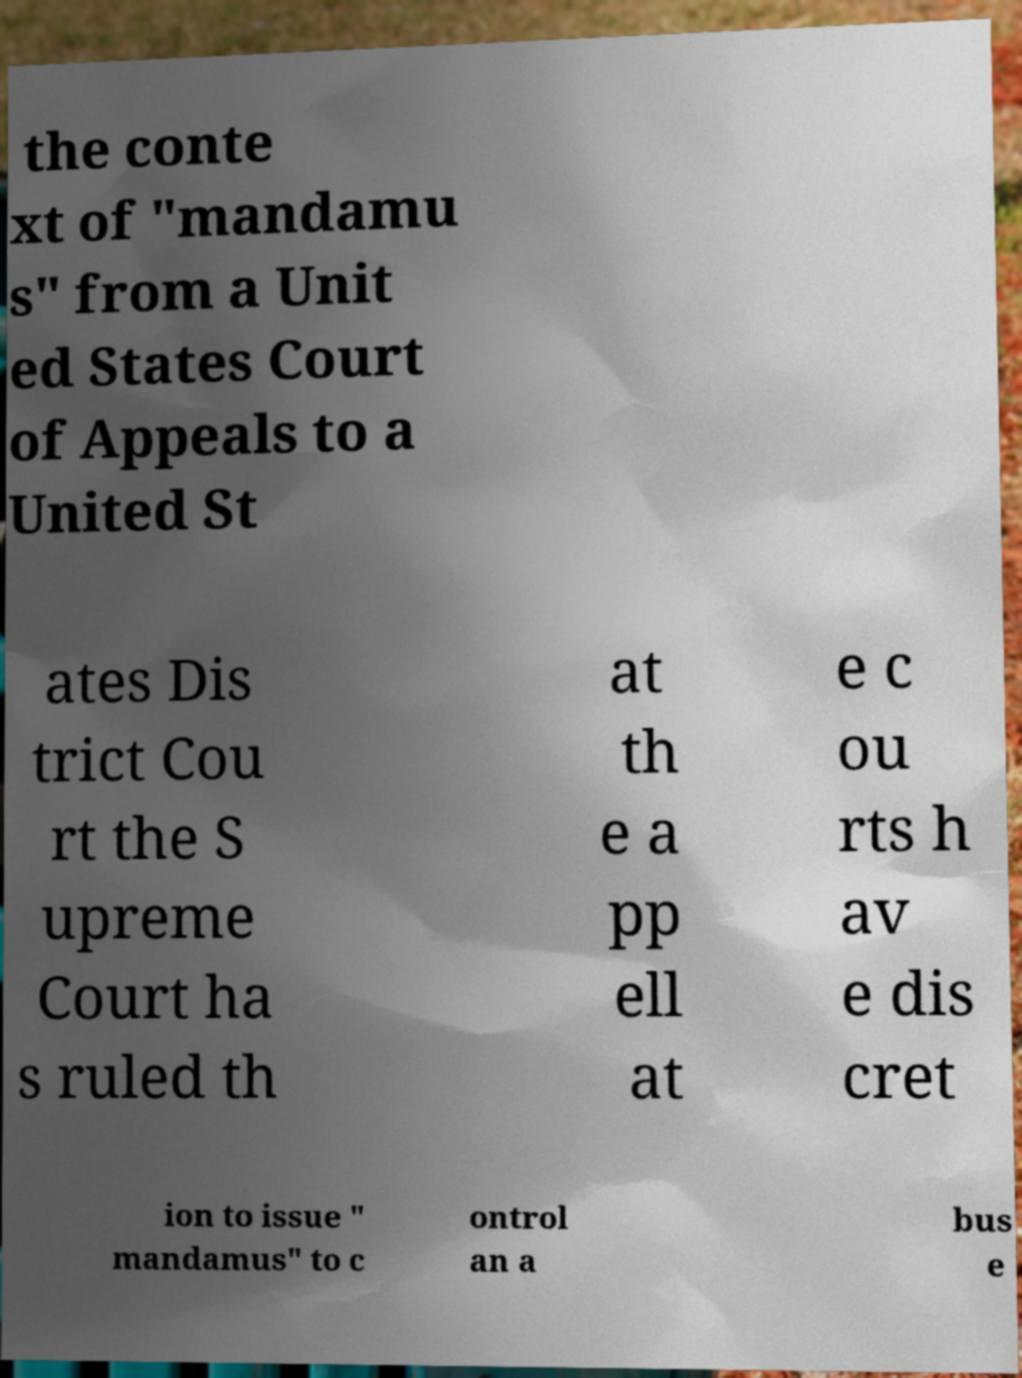Please identify and transcribe the text found in this image. the conte xt of "mandamu s" from a Unit ed States Court of Appeals to a United St ates Dis trict Cou rt the S upreme Court ha s ruled th at th e a pp ell at e c ou rts h av e dis cret ion to issue " mandamus" to c ontrol an a bus e 